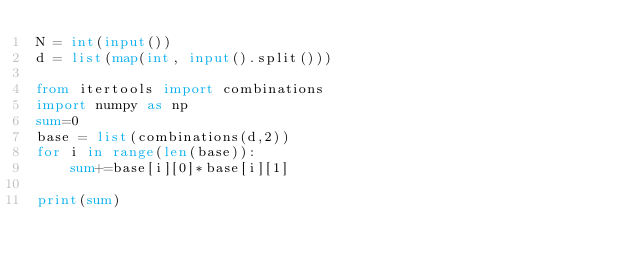<code> <loc_0><loc_0><loc_500><loc_500><_Python_>N = int(input())
d = list(map(int, input().split()))

from itertools import combinations
import numpy as np
sum=0
base = list(combinations(d,2))
for i in range(len(base)):
    sum+=base[i][0]*base[i][1]

print(sum)</code> 